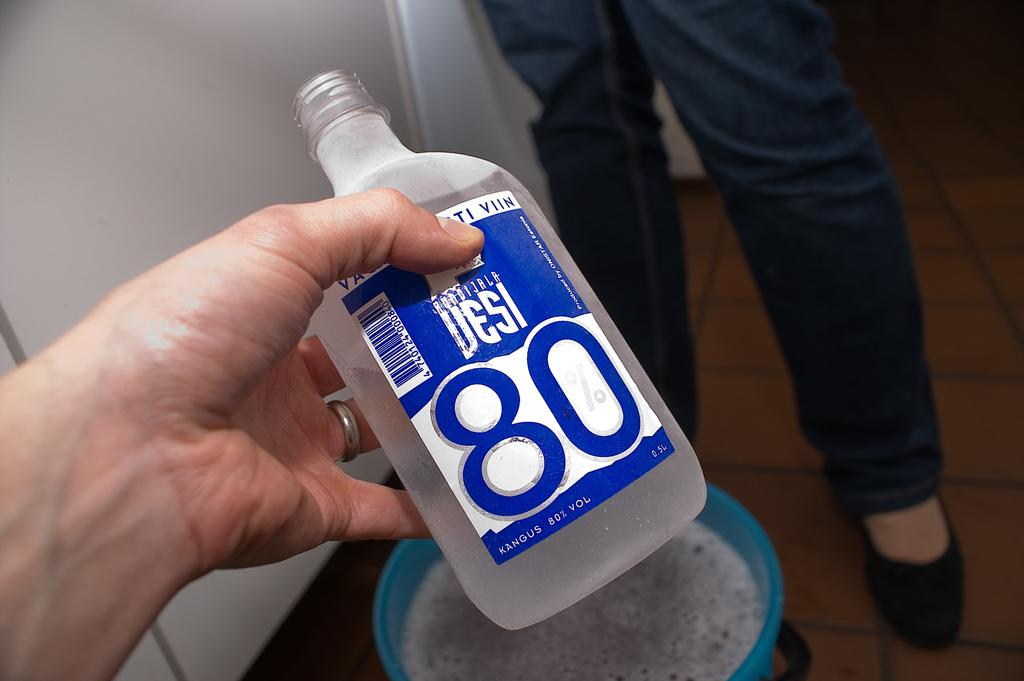<image>
Create a compact narrative representing the image presented. a left hand holding a bottle showing number 80 